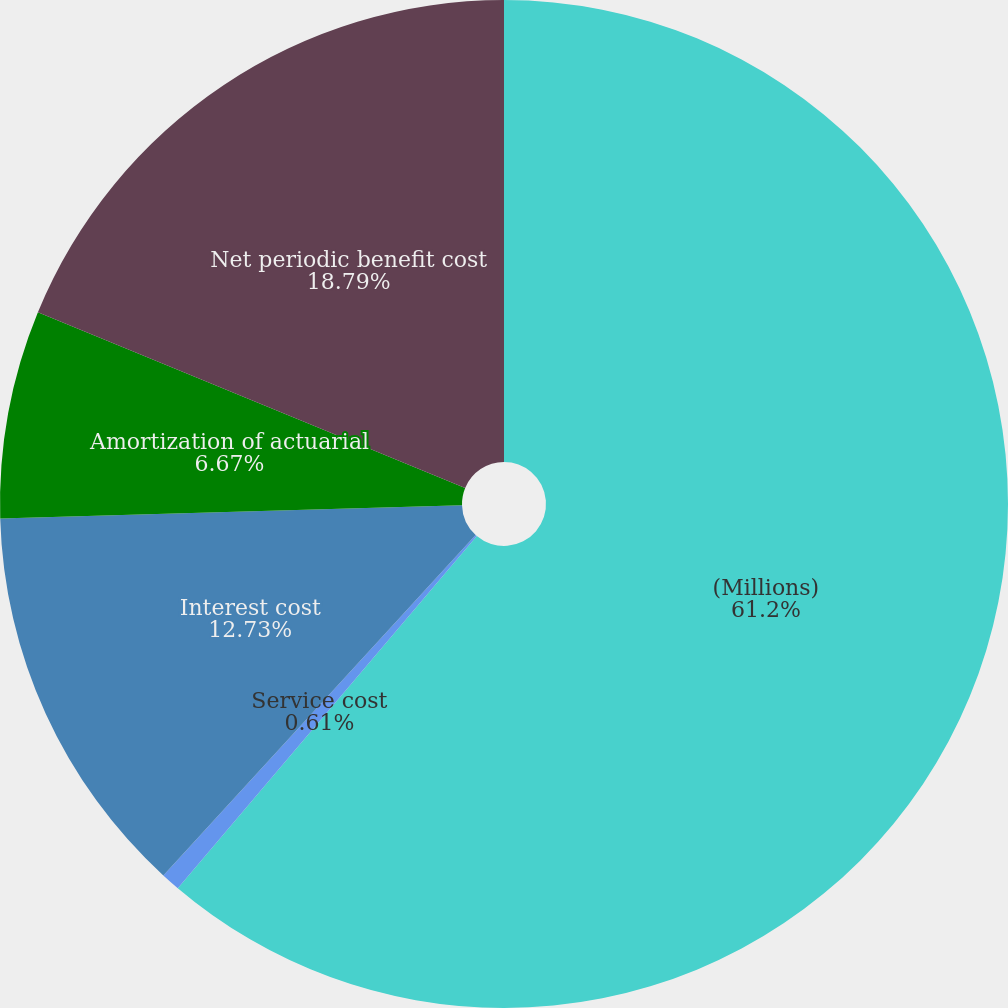<chart> <loc_0><loc_0><loc_500><loc_500><pie_chart><fcel>(Millions)<fcel>Service cost<fcel>Interest cost<fcel>Amortization of actuarial<fcel>Net periodic benefit cost<nl><fcel>61.21%<fcel>0.61%<fcel>12.73%<fcel>6.67%<fcel>18.79%<nl></chart> 